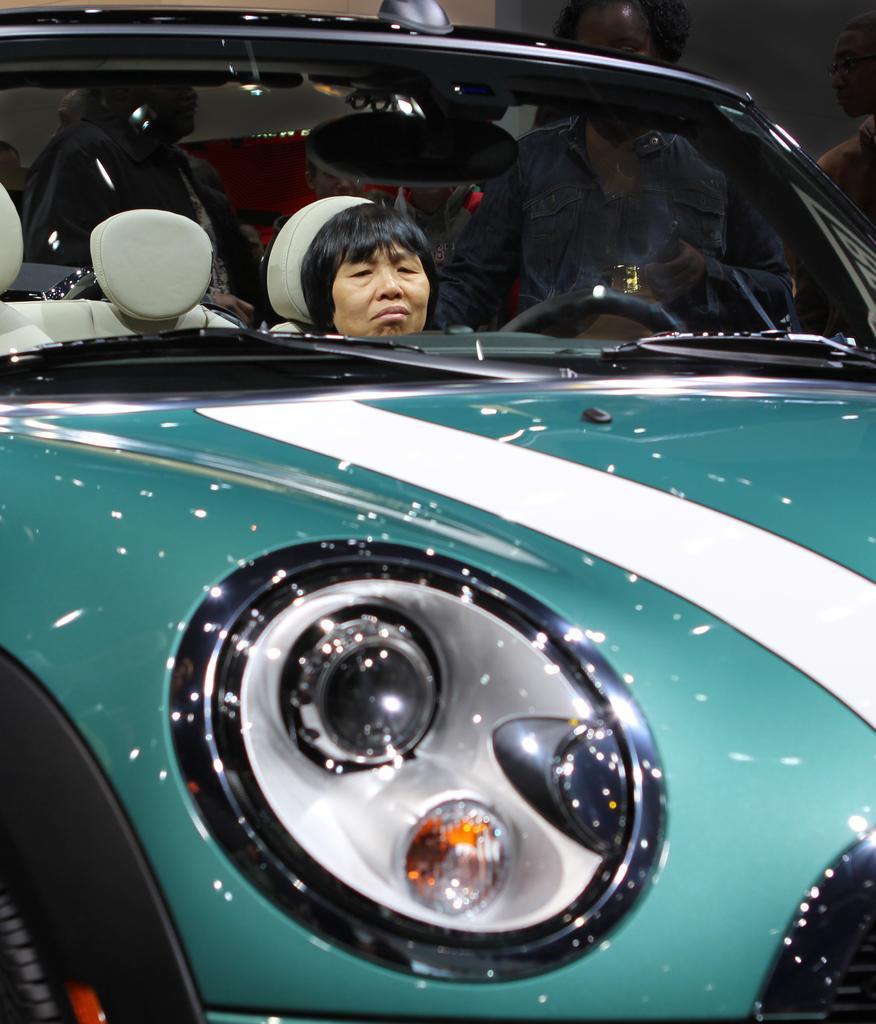In one or two sentences, can you explain what this image depicts? In this image there is one person is sitting in a car as we can see in middle of this image. There are some persons standing in the background. 